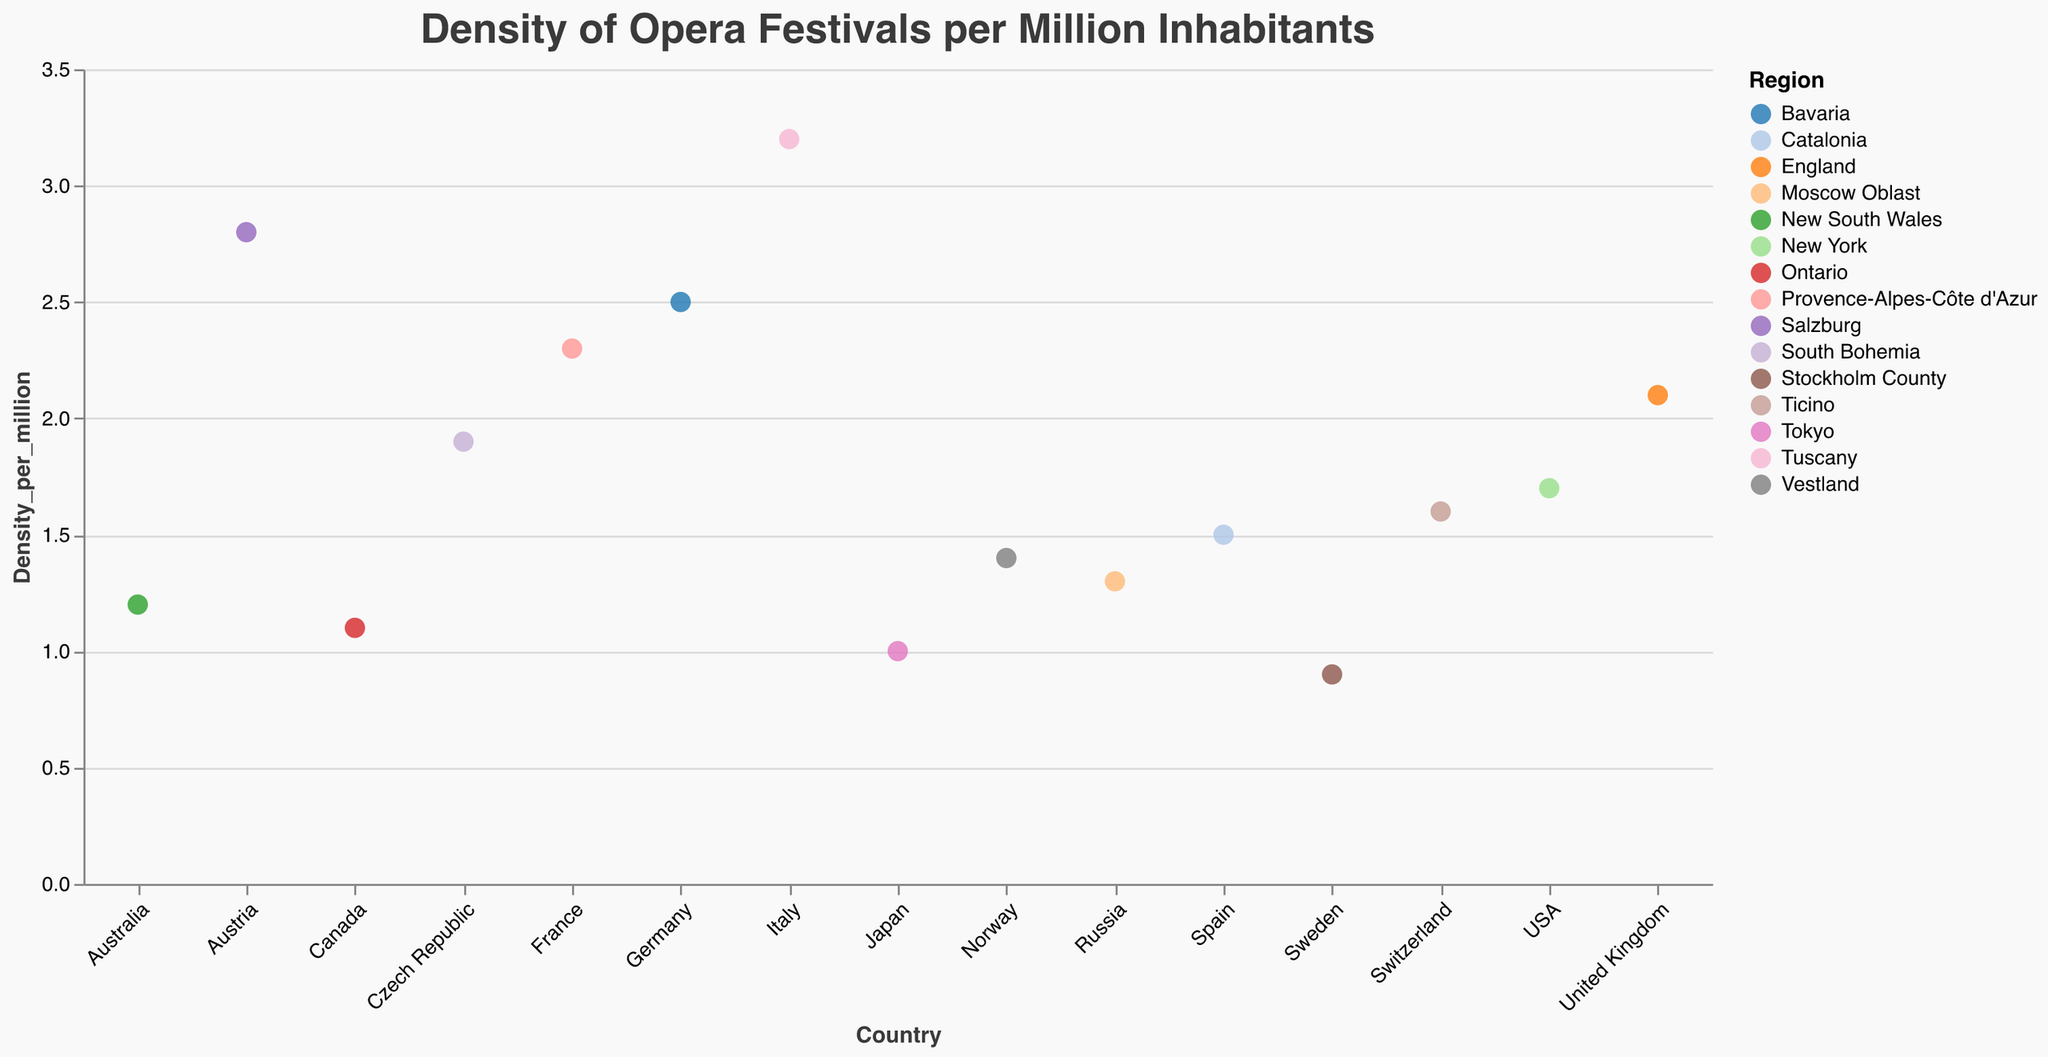what is the title of the figure? The title can be found at the top of the figure. It is in Helvetica font and has a font size of 20.
Answer: Density of Opera Festivals per Million Inhabitants Which country has the highest density of opera festivals per million inhabitants? By looking at the y-axis and identifying which country has the largest circle towards the top, we can see that Italy has the highest value.
Answer: Italy What is the density of opera festivals in New York, USA? Find New York (USA) on the x-axis and look at the y-axis value it corresponds to. It is around 1.7 per million.
Answer: 1.7 Compare the density of opera festivals in Tokyo, Japan, and Stockholm County, Sweden. Which city has a higher density? By comparing the circles for Tokyo, Japan, and Stockholm County, Sweden along the y-axis, we see that Tokyo (1.0) has a higher density than Stockholm County (0.9).
Answer: Tokyo What is the average density of opera festivals per million inhabitants across all mentioned countries? Sum up all density values and divide by the number of countries: (3.2 + 2.8 + 2.5 + 2.3 + 2.1 + 1.9 + 1.7 + 1.6 + 1.5 + 1.4 + 1.3 + 1.2 + 1.1 + 1.0 + 0.9) / 15 = 25.5 / 15.
Answer: 1.7 Which regions in Europe have a density of opera festivals greater than or equal to 2.0 per million inhabitants? Check the European countries and their corresponding regions that have a y-axis value greater than or equal to 2.0. The regions are Tuscany, Salzburg, Bavaria, Provence-Alpes-Côte d'Azur, and England.
Answer: Tuscany, Salzburg, Bavaria, Provence-Alpes-Côte d'Azur, England What is the density difference between the region with the highest density and the region with the second-highest density? Subtract the second-highest value (2.8, Salzburg) from the highest value (3.2, Tuscany): 3.2 - 2.8 = 0.4.
Answer: 0.4 Identify the non-European region or regions with a density greater than 1.5 opera festivals per million inhabitants. From the data, identify regions not in Europe that have a value greater than 1.5. New York (USA) is such a region with density 1.7.
Answer: New York (USA) What is the color representing the region with the lowest density of opera festivals, and which region is it? Look at the region with the lowest value (0.9, Stockholm County) and identify its color on the chart.
Answer: Stockholm County, Sweden (color varies depending on the category20 color scheme used) 